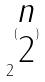Convert formula to latex. <formula><loc_0><loc_0><loc_500><loc_500>2 ^ { ( \begin{matrix} n \\ 2 \end{matrix} ) }</formula> 